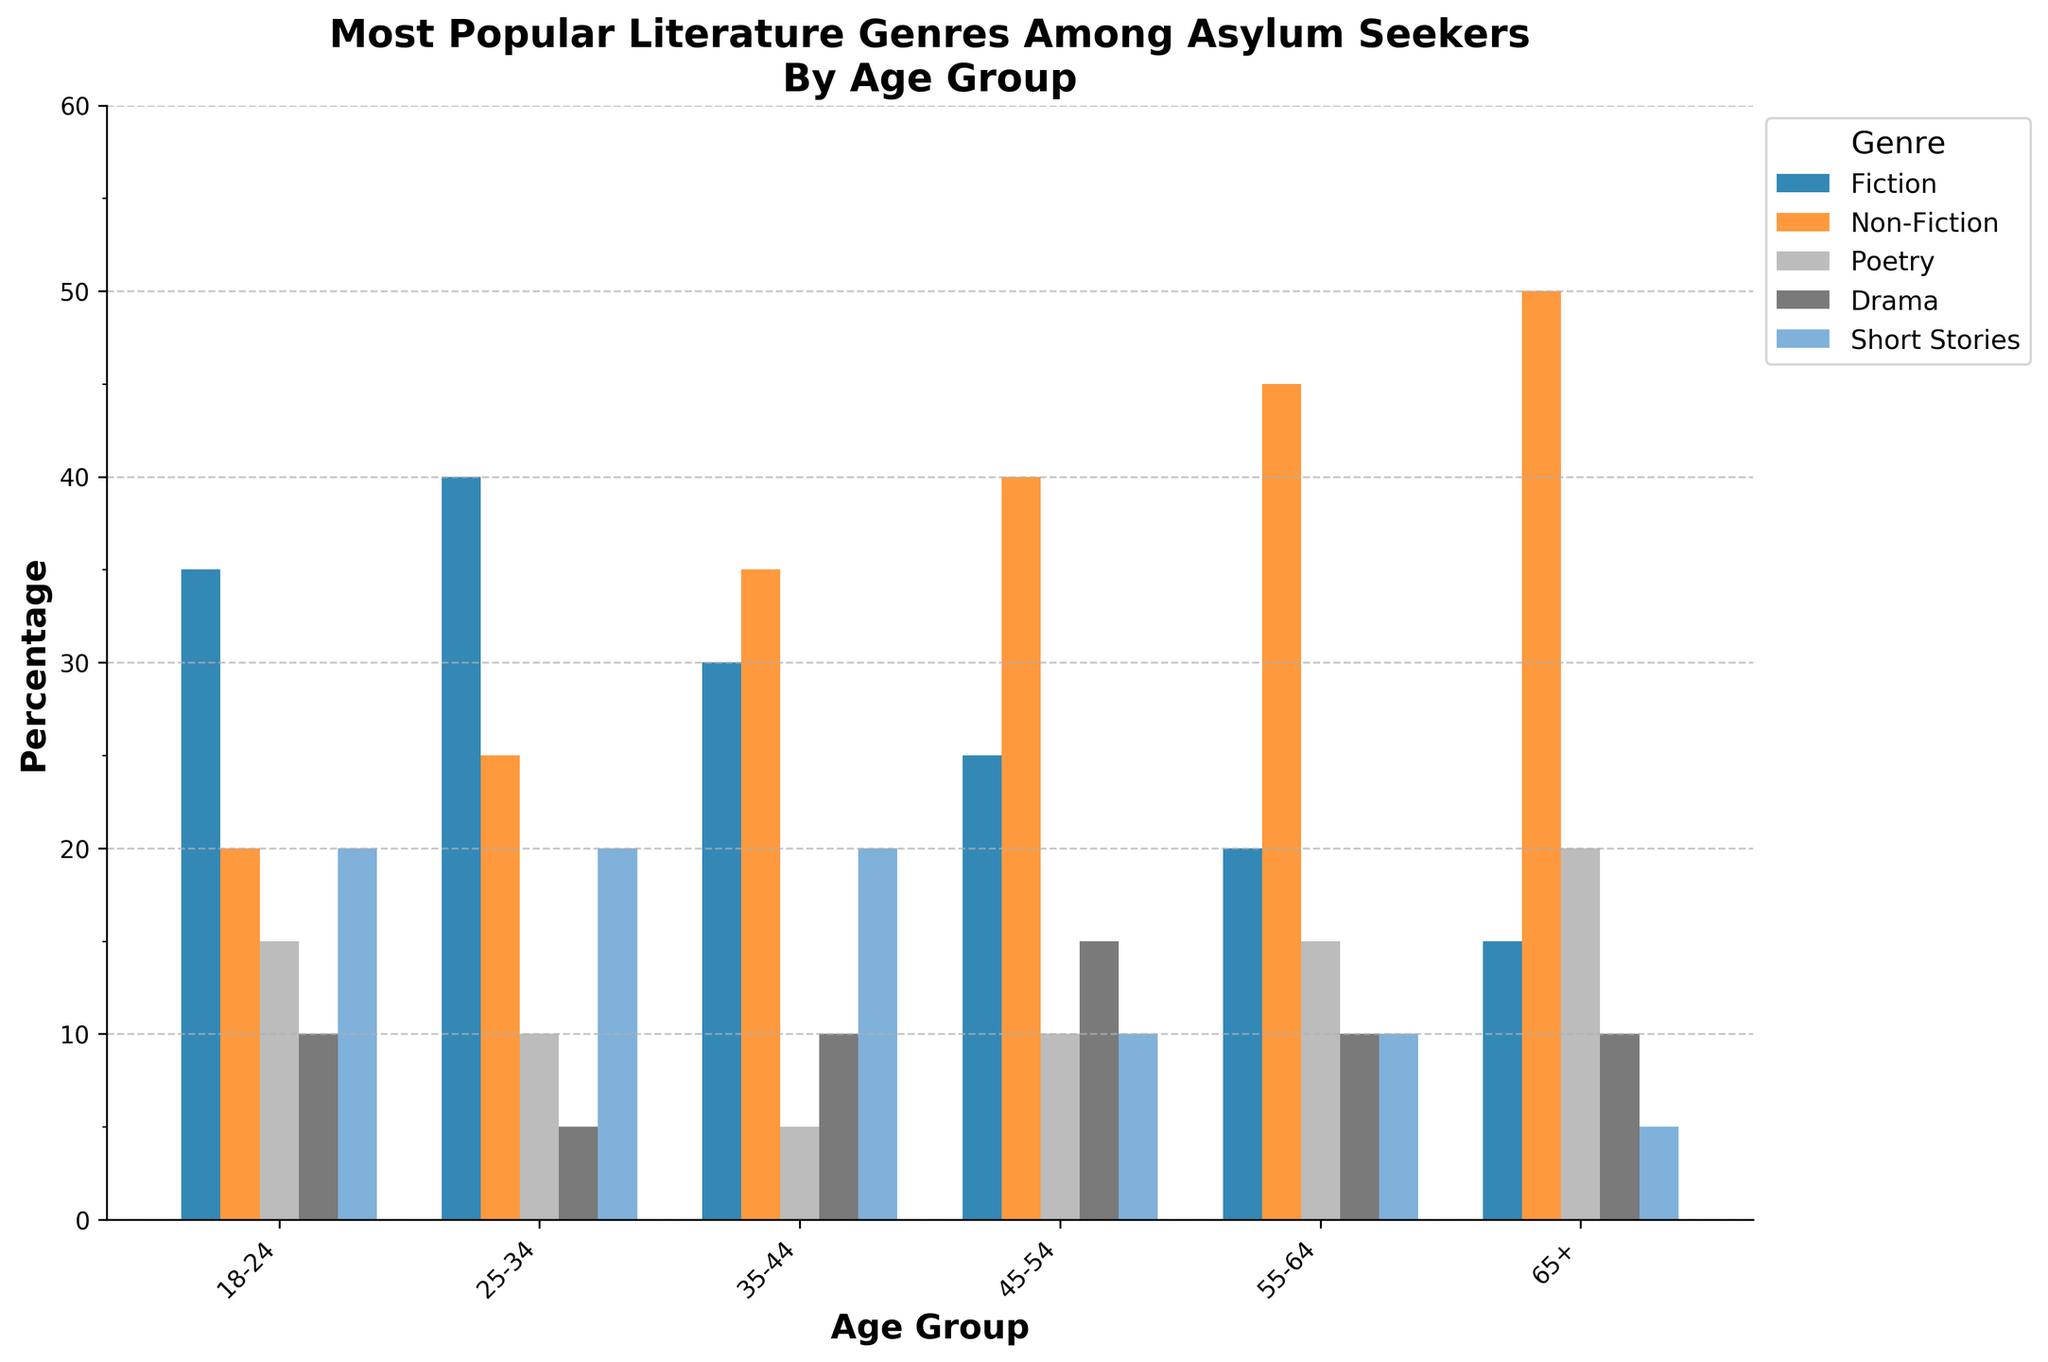Which age group has the highest preference for Non-Fiction? The tallest bar in the Non-Fiction category is for the 65+ age group, indicating this group's highest preference.
Answer: 65+ What is the sum of preferences for Poetry across all age groups? Add the percentages for Poetry across all age groups: 15 (18-24) + 10 (25-34) + 5 (35-44) + 10 (45-54) + 15 (55-64) + 20 (65+). The total is 75.
Answer: 75 Among which age group is Fiction the most popular, and what is its percentage? The highest bar in the Fiction category is for the 25-34 age group, with 40%.
Answer: 25-34, 40% Which genres are most and least popular among the 35-44 age group, and what are their percentages? The highest bar in the 35-44 age group is for Non-Fiction with 35%, and the lowest is for Poetry with 5%.
Answer: Non-Fiction 35%, Poetry 5% How does the preference for Short Stories compare between the 18-24 and the 55-64 age groups? The bar for Short Stories in the 18-24 age group is 20%, while in the 55-64 age group, it is 10%.
Answer: 18-24: 20%, 55-64: 10% What is the average preference for Drama across all age groups? Add the percentages for Drama in all age groups: 10 (18-24) + 5 (25-34) + 10 (35-44) + 15 (45-54) + 10 (55-64) + 10 (65+). The total is 60. There are 6 age groups, so the average is 60/6 = 10%.
Answer: 10% Is there any age group where the preference for Drama and Short Stories is equal? For each age group, check the bars for Drama and Short Stories. The 18-24 and 25-34 age groups each have 10% for both Drama and Short Stories.
Answer: 18-24, 25-34 What is the difference in preference for Fiction between the 25-34 and 45-54 age groups? The bar for Fiction in the 25-34 age group is 40%, and in the 45-54 age group, it is 25%. The difference is 40% - 25% = 15%.
Answer: 15% Which genre shows a noticeable increase in popularity as age increases from 18-24 to 65+? Non-Fiction shows a noticeable increase, with percentages rising from 20% (18-24) to 50% (65+).
Answer: Non-Fiction What is the total percentage of Fiction readers across the 18-24 and 35-44 age groups? Add percentages for Fiction in these age groups: 35% (18-24) + 30% (35-44). The total is 65%.
Answer: 65% 